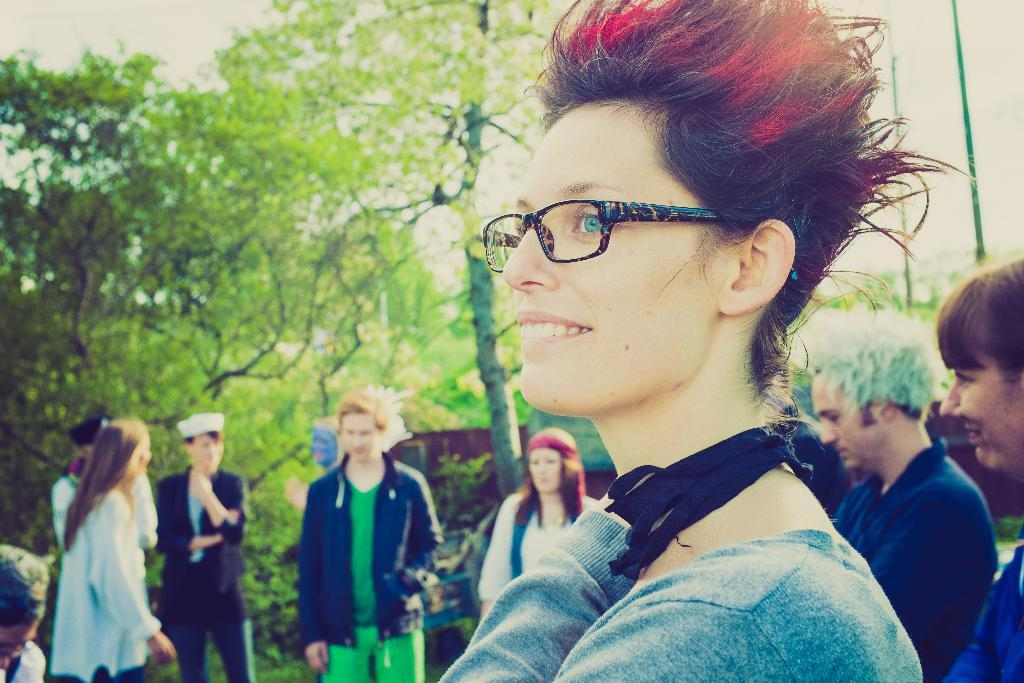What is the woman in the image wearing? The woman in the image is wearing glasses. How many people are in the group visible in the image? There is a group of people standing in the image. What type of vegetation is present in the image? There is a group of trees in the image. What structures can be seen in the image? There are poles visible in the image. What is the weather like in the image? The sky appears cloudy in the image. What committee is the ghost attending in the image? There is no ghost present in the image, and therefore no committee to attend. 